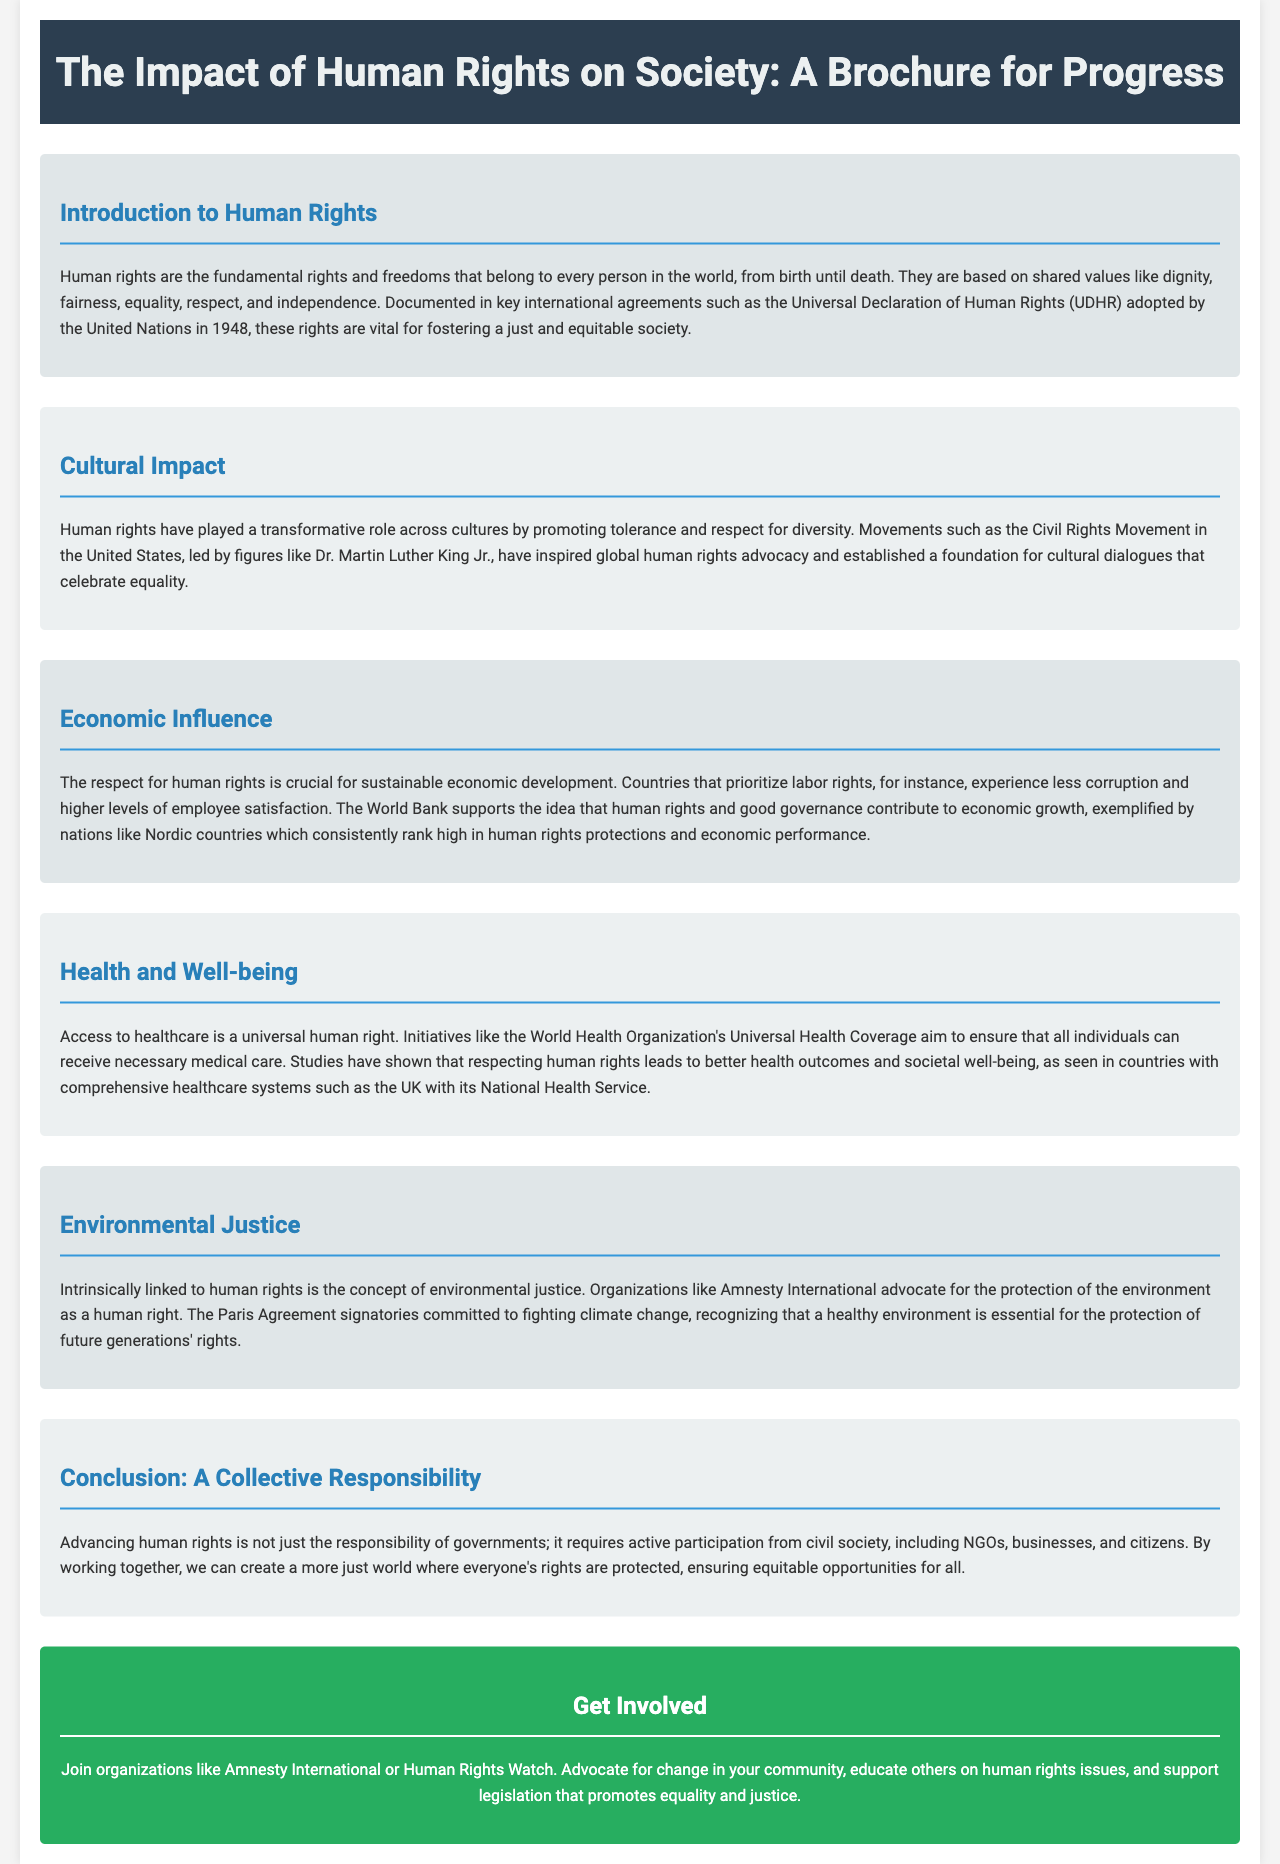What is the title of the brochure? The title of the brochure is clearly stated at the top of the document.
Answer: The Impact of Human Rights on Society: A Brochure for Progress According to the brochure, when was the Universal Declaration of Human Rights adopted? The brochure mentions the year in which the Universal Declaration of Human Rights was adopted by the United Nations.
Answer: 1948 Which movement is highlighted in the section about cultural impact? The brochure discusses a specific movement that has influenced global human rights advocacy.
Answer: Civil Rights Movement What is a key benefit of respecting human rights mentioned in the economic influence section? The brochure states the relation between human rights and economic development in terms of a specific aspect.
Answer: Sustainable economic development What organization is mentioned in relation to environmental justice? The brochure identifies an organization that advocates for environmental justice as a human right.
Answer: Amnesty International What health initiative is referenced in the health and well-being section? The brochure discusses a worldwide initiative that aims to ensure healthcare access for all individuals.
Answer: Universal Health Coverage What does the brochure list as a collective responsibility in advancing human rights? The conclusion emphasizes a particular aspect necessary for advancing human rights effectively.
Answer: Active participation How can individuals get involved according to the brochure? The brochure suggests methods for individuals to engage with human rights advocacy.
Answer: Join organizations like Amnesty International or Human Rights Watch 